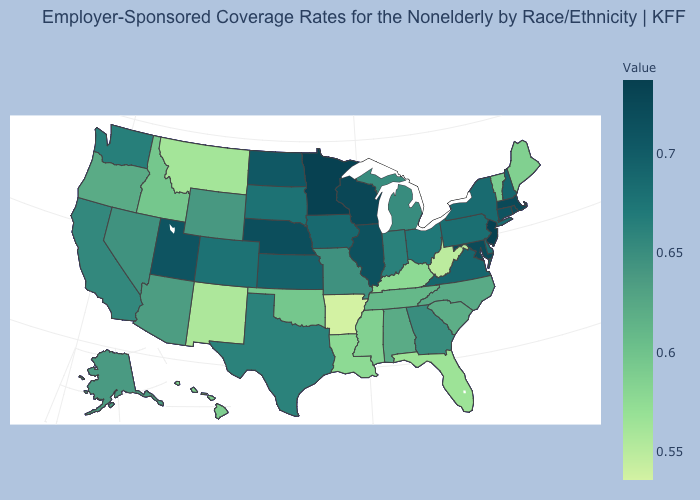Which states hav the highest value in the West?
Answer briefly. Utah. Which states have the lowest value in the USA?
Give a very brief answer. Arkansas. Which states have the lowest value in the Northeast?
Quick response, please. Maine. Does Utah have the highest value in the West?
Write a very short answer. Yes. Does Utah have the highest value in the West?
Be succinct. Yes. Does the map have missing data?
Keep it brief. No. Does New Hampshire have the highest value in the USA?
Write a very short answer. No. 